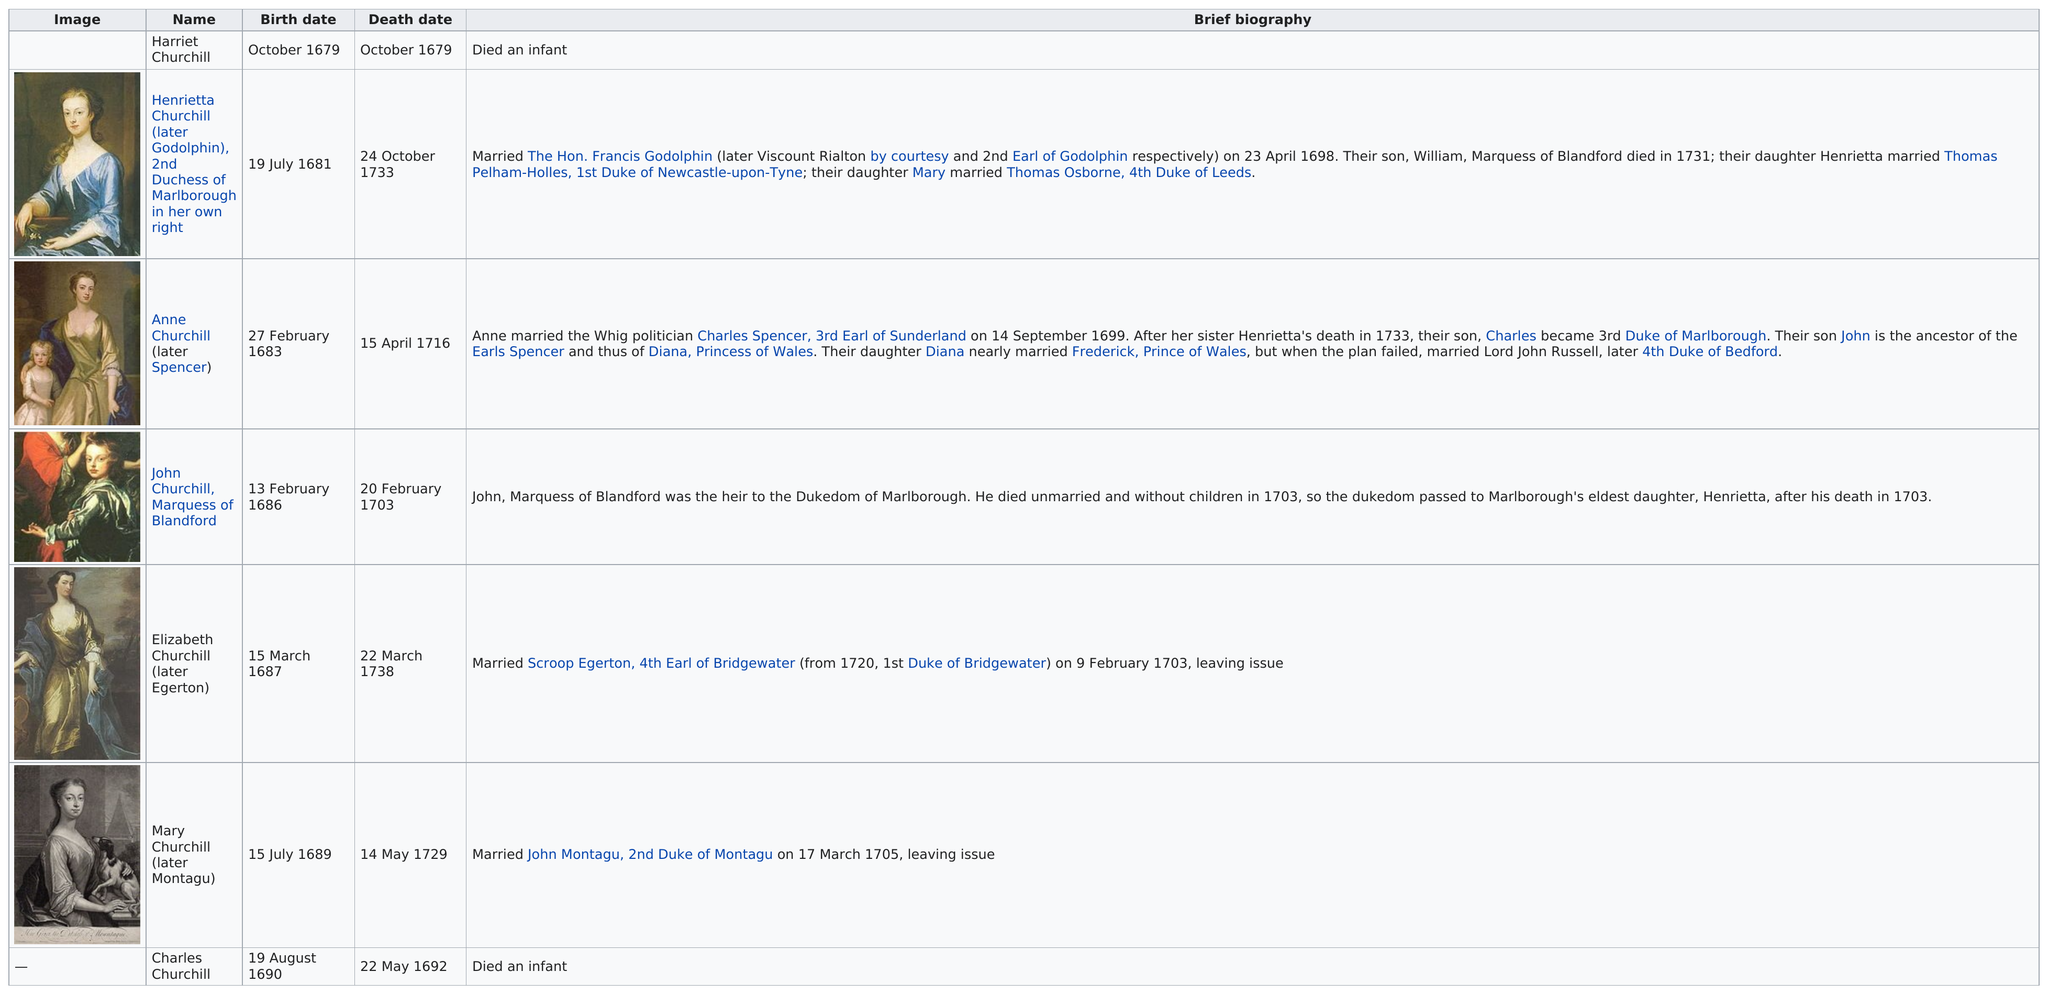List a handful of essential elements in this visual. Harriet Churchill was born before Henrietta. Two children were born in February. In total, the number of children born after 1675 is 7. Sarah Churchill gave birth to her first child on October 1679. Sarah Churchill had seven children. 